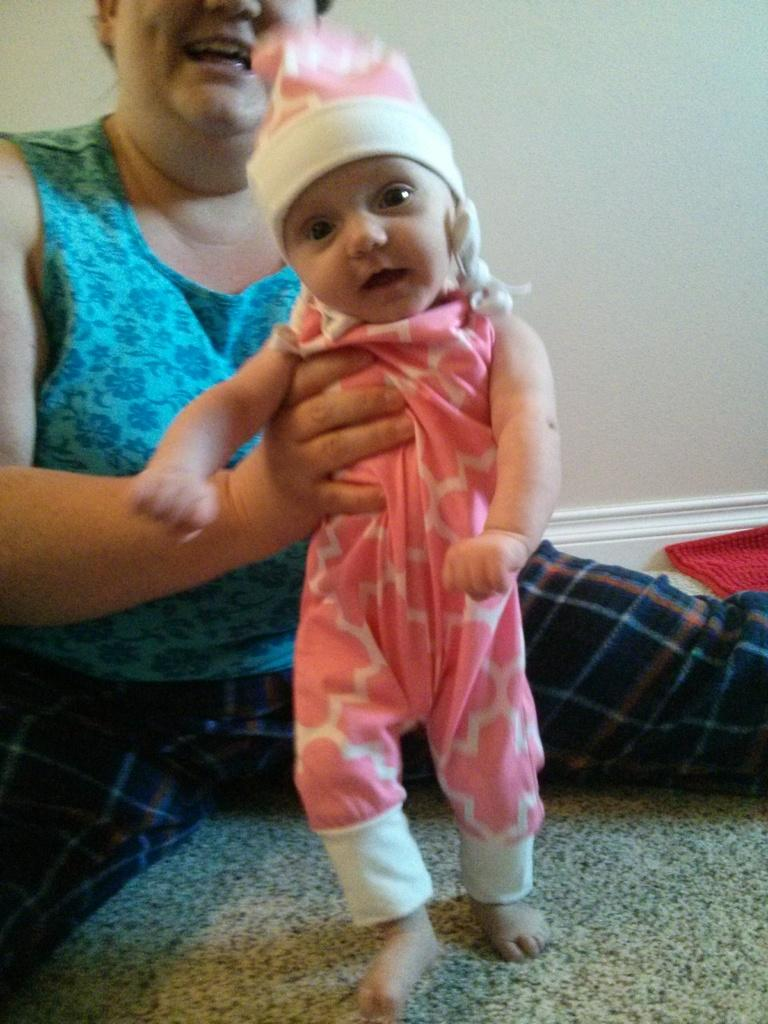Who is the main subject in the image? There is a woman in the image. What is the woman doing in the image? The woman is holding a baby. What can be seen in the background of the image? There is a wall in the background of the image. What type of mouth does the creator of the image have? There is no information about the creator of the image, nor is there any indication of a mouth in the image. 